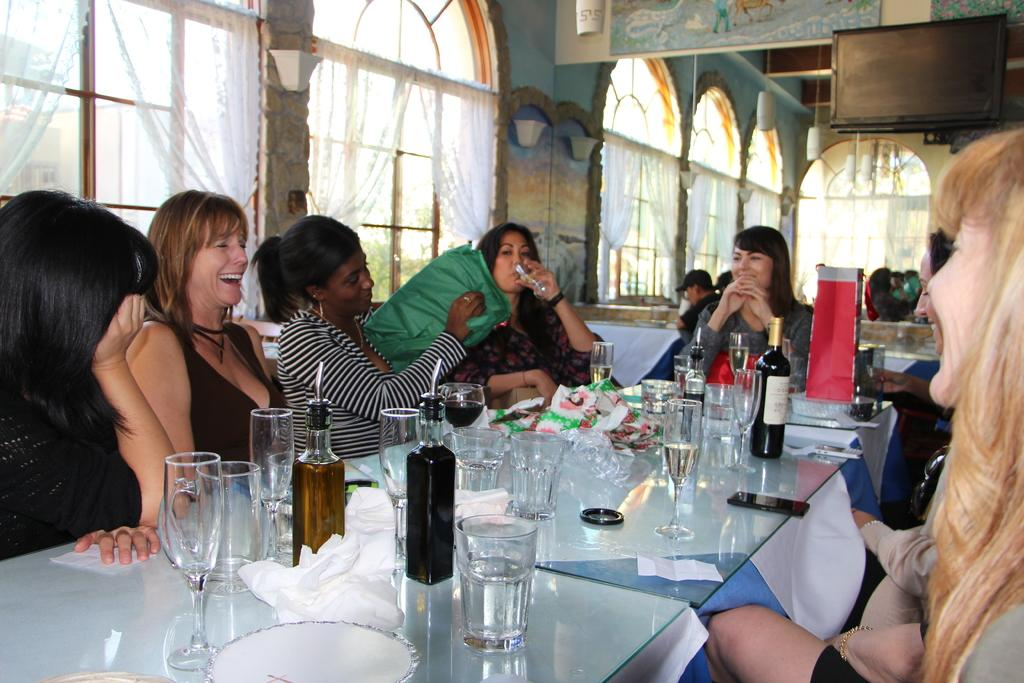What are the people in the image doing? The people in the image are sitting on chairs. What can be seen on the table in the image? There are wine glasses and wine bottles on the table. How many circles can be seen on the table in the image? There are no circles visible on the table in the image. What type of division is taking place in the image? There is no division taking place in the image; it simply shows people sitting on chairs and wine glasses and bottles on a table. 